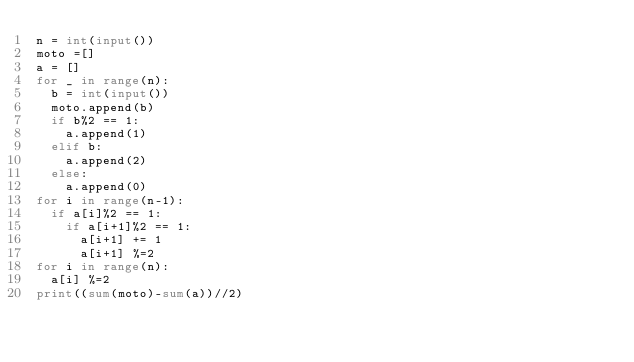Convert code to text. <code><loc_0><loc_0><loc_500><loc_500><_Python_>n = int(input())
moto =[]
a = []
for _ in range(n):
  b = int(input())
  moto.append(b)
  if b%2 == 1:
    a.append(1)
  elif b:
    a.append(2)
  else:
    a.append(0)
for i in range(n-1):
  if a[i]%2 == 1:
    if a[i+1]%2 == 1:
      a[i+1] += 1
      a[i+1] %=2
for i in range(n):
  a[i] %=2
print((sum(moto)-sum(a))//2)</code> 